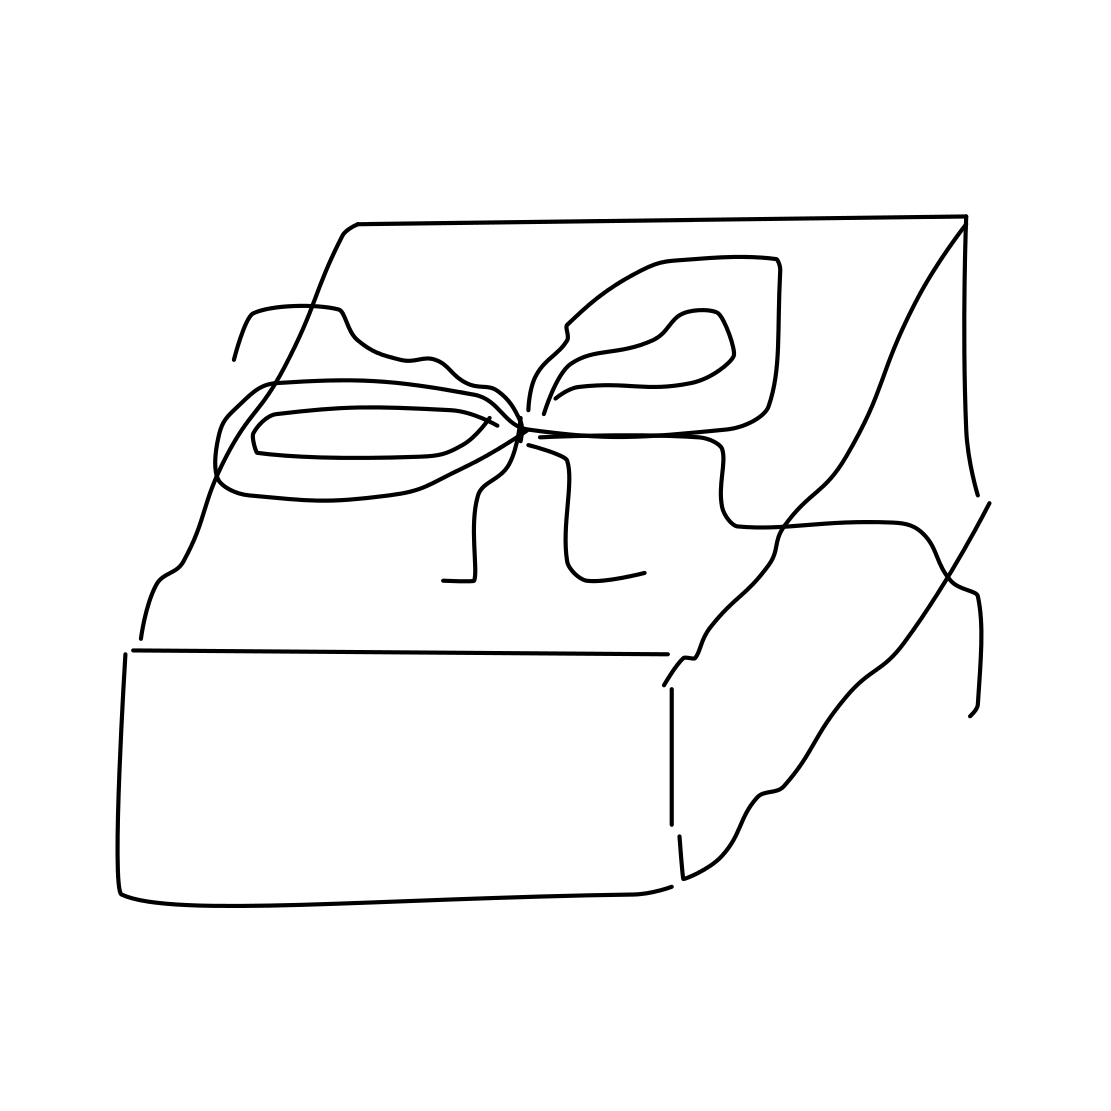What is the occasion for the present shown in this image? While the specific occasion isn't clear just from the image, the presence of a neatly wrapped gift typically suggests celebrations such as a birthday, anniversary, or a special holiday. 